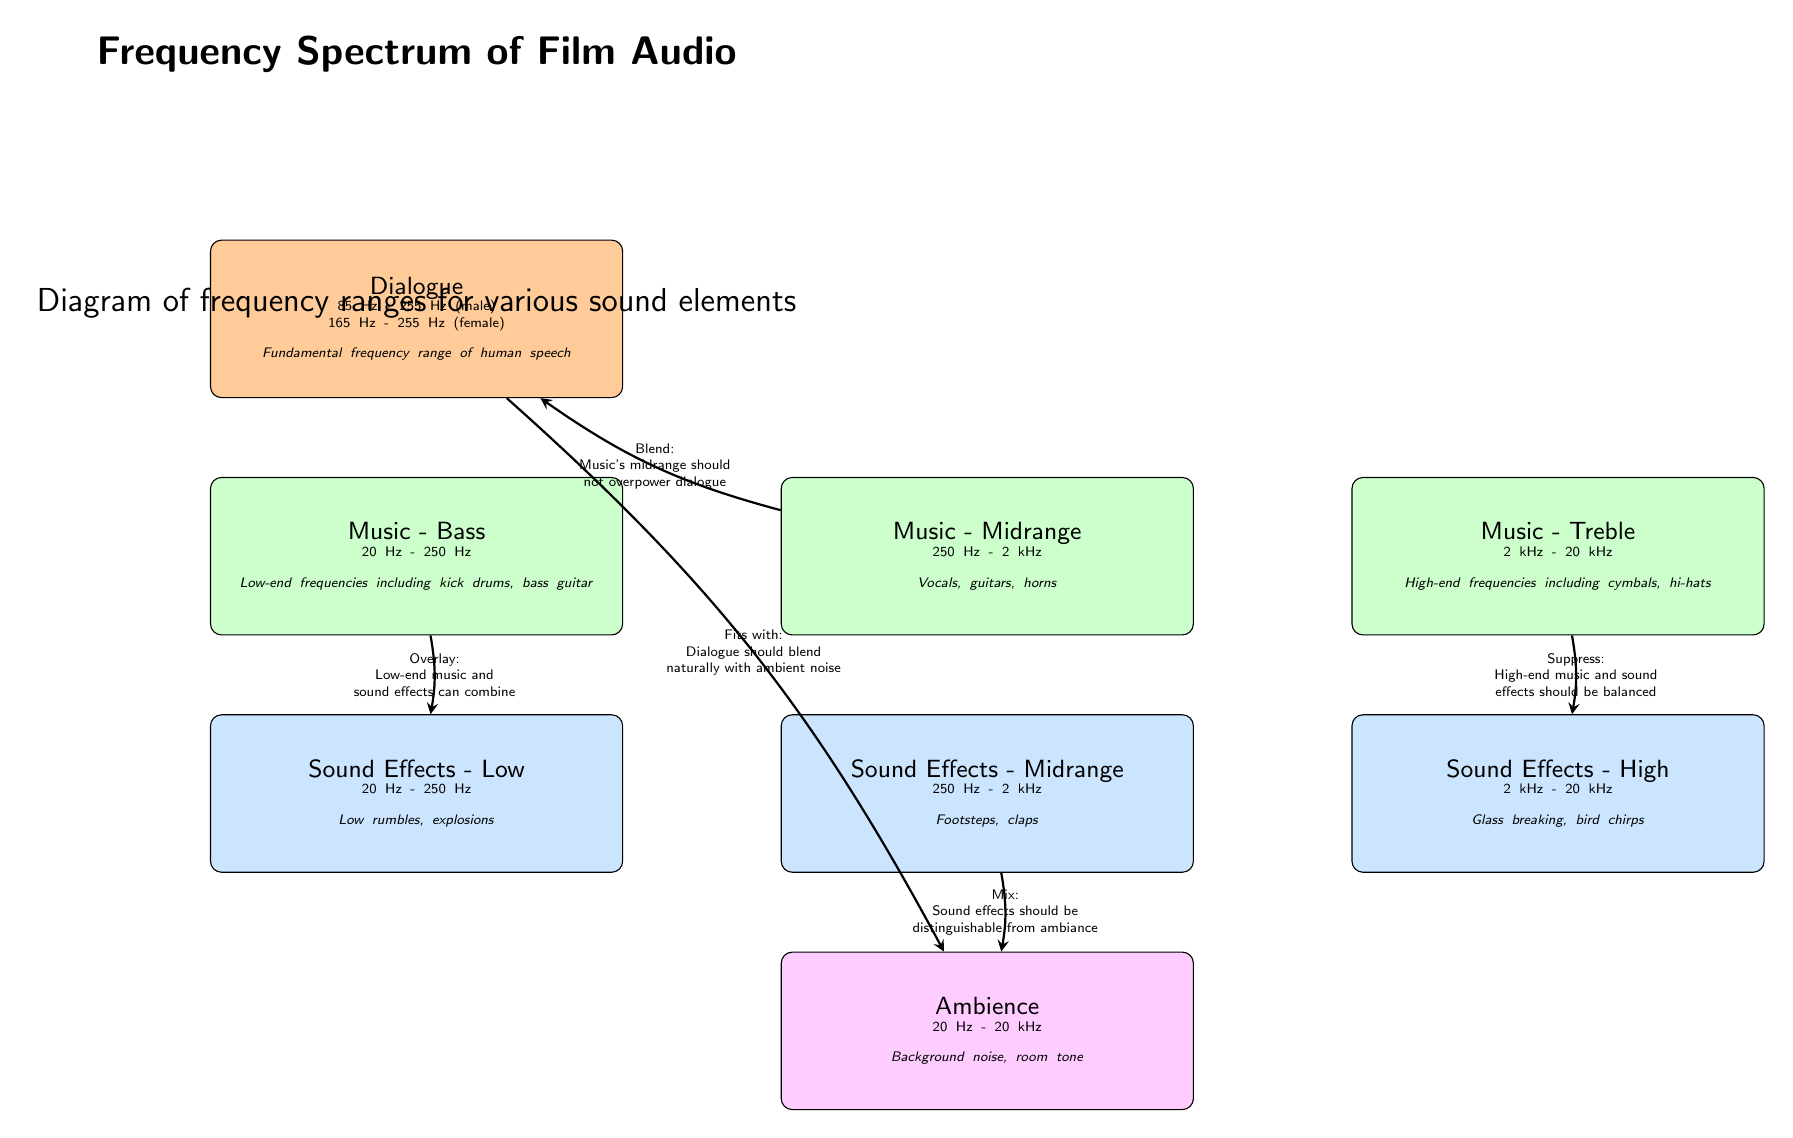What is the frequency range of dialogue? The diagram shows that the frequency range for dialogue is from 85 Hz to 255 Hz for male voices and from 165 Hz to 255 Hz for female voices. Therefore, the range is specifically stated in the box labeled "Dialogue".
Answer: 85 Hz - 255 Hz (male); 165 Hz - 255 Hz (female) What sound elements fall under music's midrange? According to the diagram, the music's midrange includes vocals, guitars, and horns, which are explicitly listed in the box labeled "Music - Midrange".
Answer: Vocals, guitars, horns What is the frequency range for ambience? The diagram specifies that the frequency range for ambience is from 20 Hz to 20 kHz. This information is found in the box labeled "Ambience".
Answer: 20 Hz - 20 kHz How should music's midrange interact with dialogue? The diagram indicates that music's midrange should blend, meaning it should not overpower dialogue. This information is shown in the arrow connecting "Music - Midrange" and "Dialogue", accompanied by a label explaining the relationship.
Answer: Blend Which sound effects combine with low-end music? The diagram states that low-end music can combine with low sound effects, specifically highlighted in the arrow connecting "Music - Bass" and "Sound Effects - Low". This relationship is captured in the labeled arrow indicating the way they fit together.
Answer: Low sound effects What should be balanced with high-end music? The diagram notes that high-end music and sound effects should be balanced, as indicated by the arrow pointing from "Music - Treble" to "Sound Effects - High". This explains the need for balance in the upper frequency ranges.
Answer: Sound effects How many main categories are represented in the diagram? By reviewing the diagram, we see four main categories outlined: Dialogue, Music (with three subdivisions), Sound Effects (with three subdivisions), and Ambience. Counting these categories gives us a total of four.
Answer: Four What does the arrow between dialogue and ambience indicate? The arrow in the diagram indicates that dialogue should blend naturally with ambient noise, demonstrating the interplay between these two elements to create an immersive audio experience. This is explicitly stated in the label of the connecting arrow.
Answer: Dialogue should blend naturally with ambient noise What type of sounds do ambient frequencies encompass? The diagram describes ambient frequencies as including background noise and room tone, which captures the broader definition of what ambiance entails in the context of film audio. This is stated in the box labeled "Ambience".
Answer: Background noise, room tone 